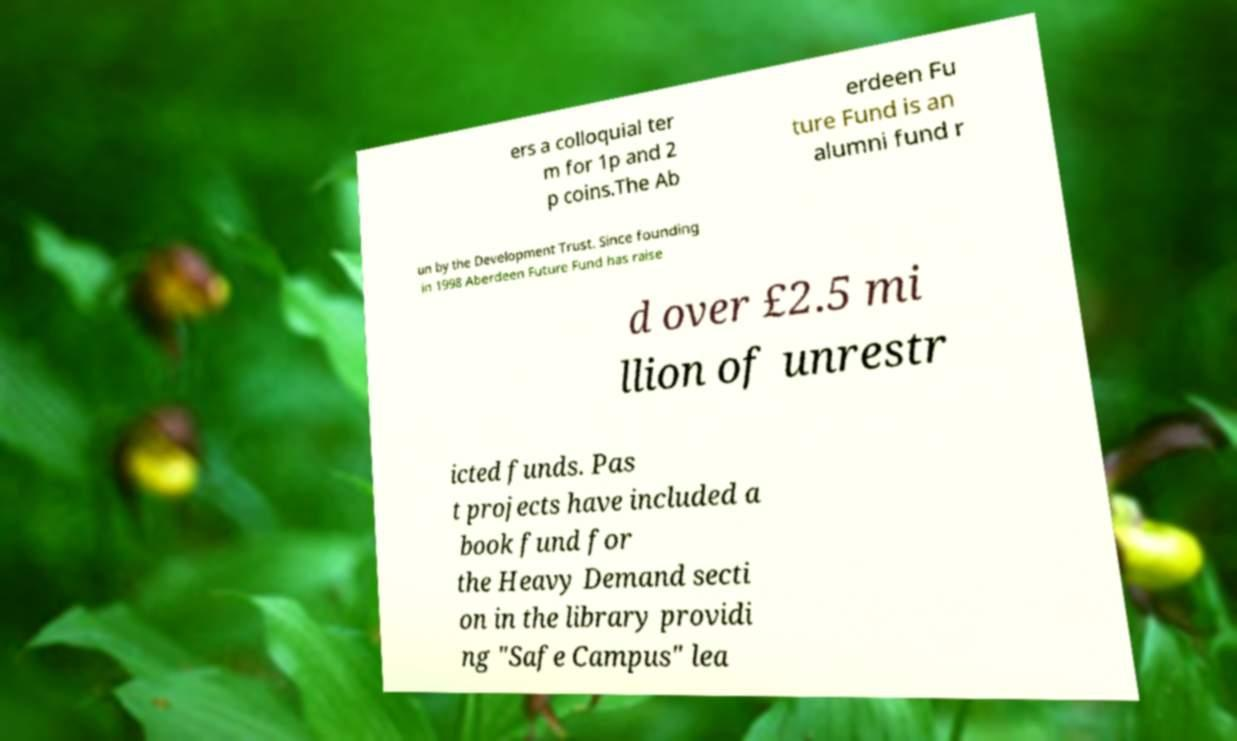Can you read and provide the text displayed in the image?This photo seems to have some interesting text. Can you extract and type it out for me? ers a colloquial ter m for 1p and 2 p coins.The Ab erdeen Fu ture Fund is an alumni fund r un by the Development Trust. Since founding in 1998 Aberdeen Future Fund has raise d over £2.5 mi llion of unrestr icted funds. Pas t projects have included a book fund for the Heavy Demand secti on in the library providi ng "Safe Campus" lea 